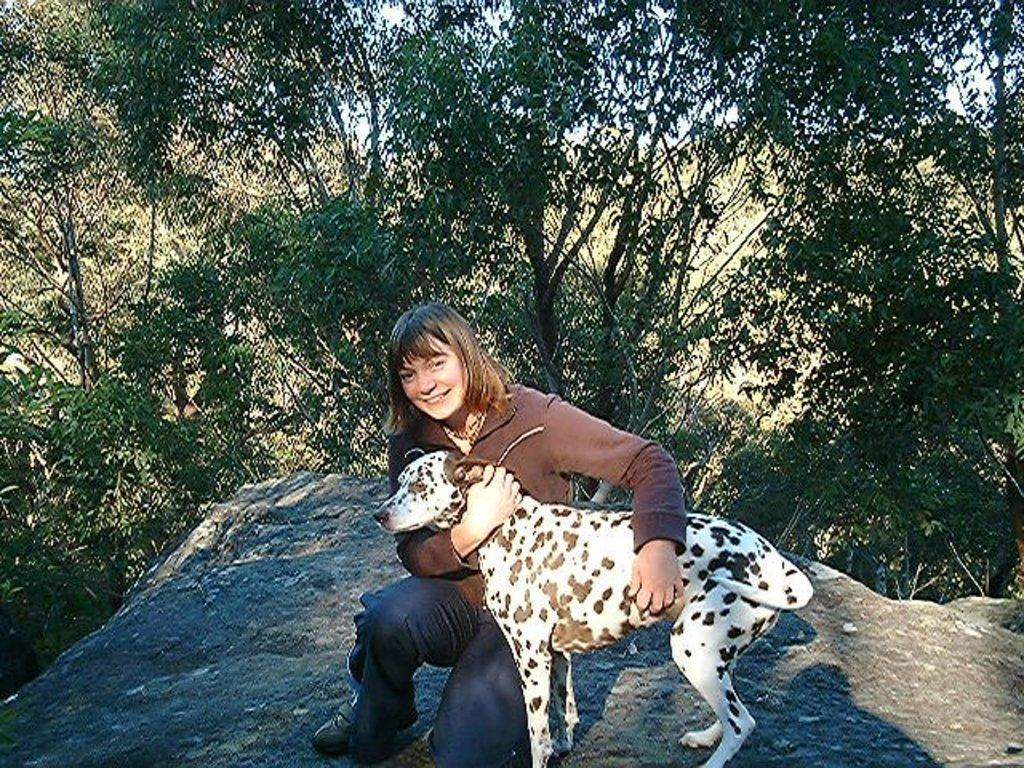Who is the main subject in the image? There is a woman in the image. What is the woman doing in the image? The woman is sitting. What is the woman holding in the image? The woman is holding a dog. What can be seen in the background of the image? There are trees, the sky, and a rock in the background of the image. What type of soup is being served on the side in the image? There is no soup present in the image; the woman is holding a dog. 